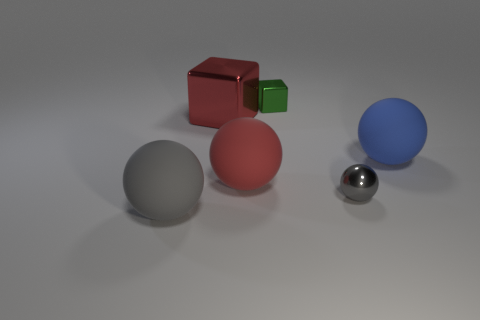Add 4 green shiny cubes. How many objects exist? 10 Subtract all tiny shiny spheres. How many spheres are left? 3 Subtract all red cubes. How many gray spheres are left? 2 Subtract all blocks. How many objects are left? 4 Subtract all red spheres. How many spheres are left? 3 Subtract 0 purple cylinders. How many objects are left? 6 Subtract 1 cubes. How many cubes are left? 1 Subtract all yellow blocks. Subtract all cyan spheres. How many blocks are left? 2 Subtract all metal cubes. Subtract all tiny green blocks. How many objects are left? 3 Add 1 large metallic objects. How many large metallic objects are left? 2 